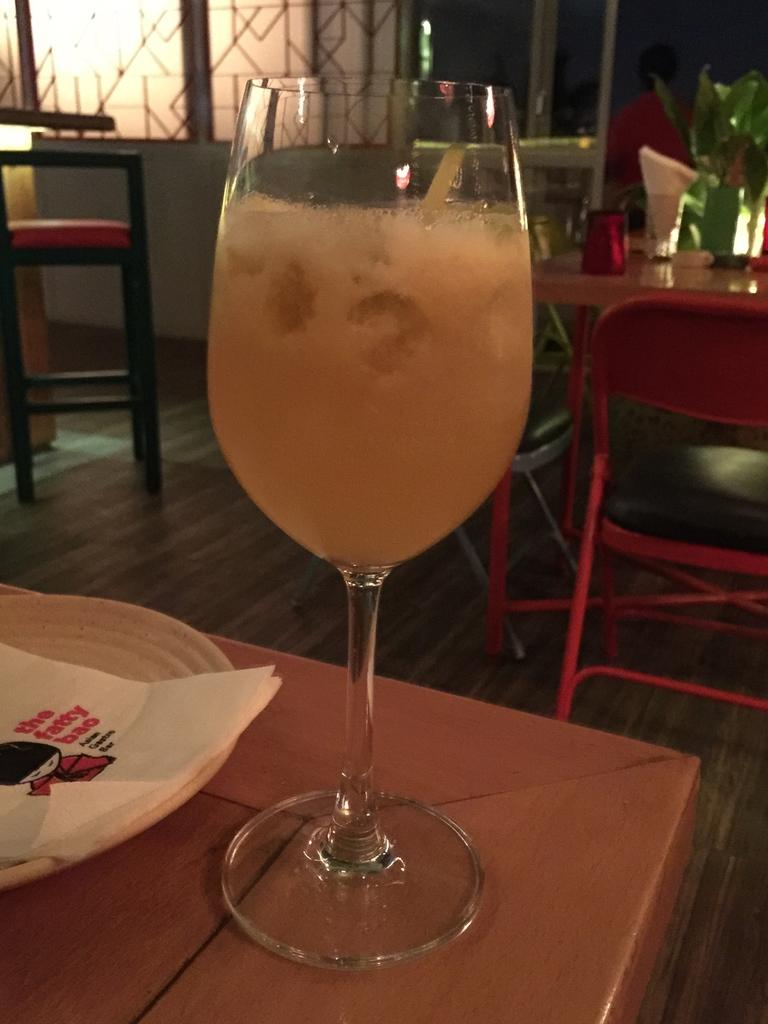What is on the table in the image? There is a glass and a plate on the table in the image. What is on the plate? A tissue is present on the plate. Where are the glass and plate located? They are on a table. What can be seen in the background of the image? There are chairs and another table with items on it in the background of the image. What type of rod is being used by the team in the image? There is no rod or team present in the image; it only features a glass, a plate, a tissue, chairs, and another table with items on it. 